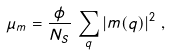Convert formula to latex. <formula><loc_0><loc_0><loc_500><loc_500>\mu _ { m } = \frac { \phi } { N _ { S } } \, \sum _ { q } \left | m ( { q } ) \right | ^ { 2 } \, ,</formula> 